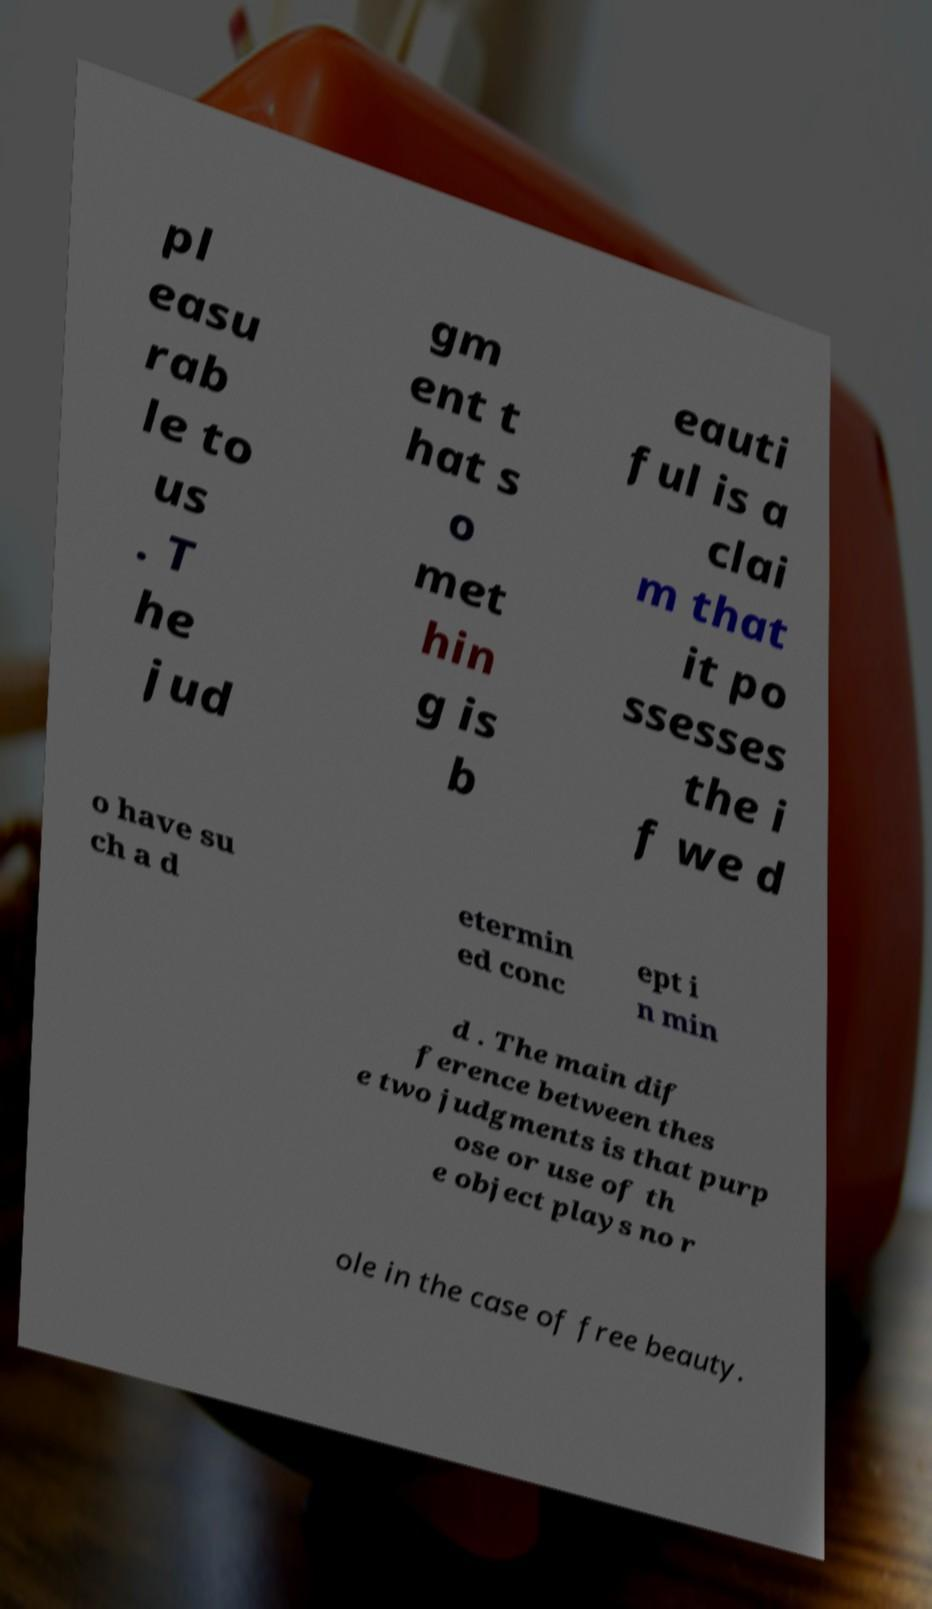Could you assist in decoding the text presented in this image and type it out clearly? pl easu rab le to us . T he jud gm ent t hat s o met hin g is b eauti ful is a clai m that it po ssesses the i f we d o have su ch a d etermin ed conc ept i n min d . The main dif ference between thes e two judgments is that purp ose or use of th e object plays no r ole in the case of free beauty. 